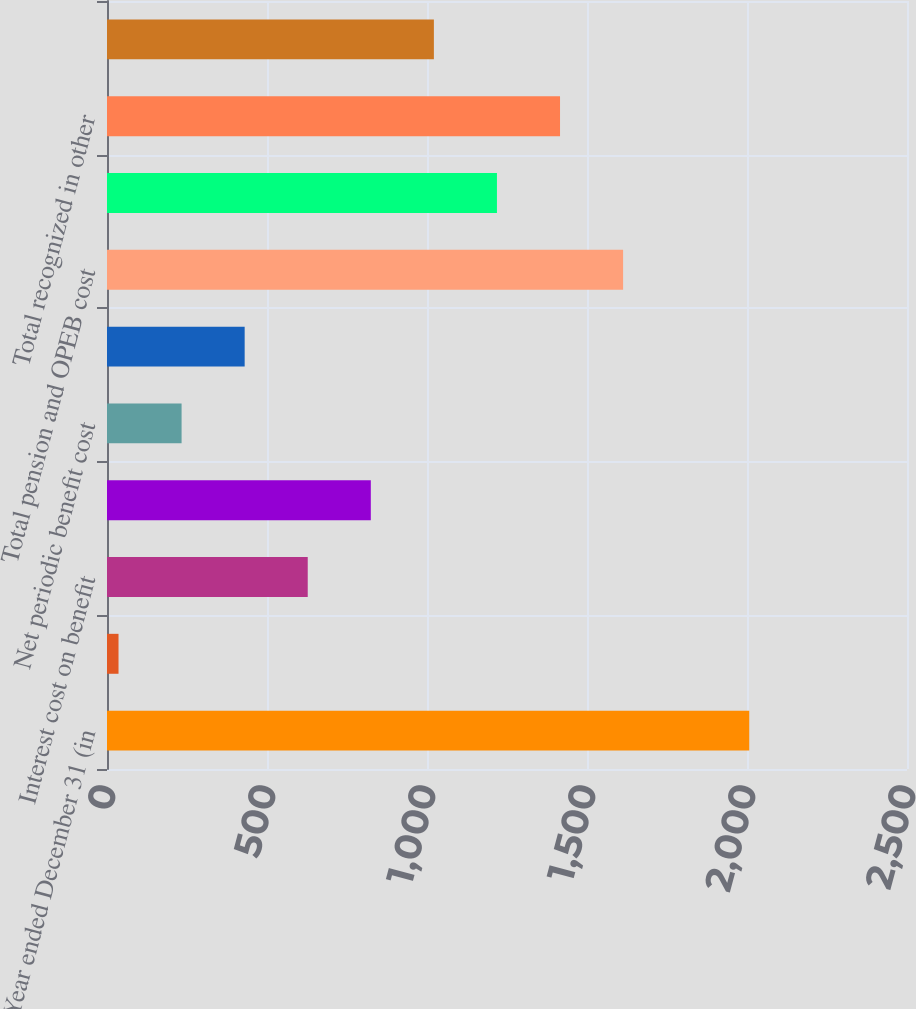<chart> <loc_0><loc_0><loc_500><loc_500><bar_chart><fcel>Year ended December 31 (in<fcel>Benefits earned during the<fcel>Interest cost on benefit<fcel>Expected return on plan assets<fcel>Net periodic benefit cost<fcel>Total defined benefit plans<fcel>Total pension and OPEB cost<fcel>Net (gain)/loss arising during<fcel>Total recognized in other<fcel>Total recognized in net<nl><fcel>2007<fcel>36<fcel>627.3<fcel>824.4<fcel>233.1<fcel>430.2<fcel>1612.8<fcel>1218.6<fcel>1415.7<fcel>1021.5<nl></chart> 